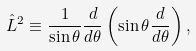<formula> <loc_0><loc_0><loc_500><loc_500>\hat { L } ^ { 2 } \equiv \frac { 1 } { \sin { \theta } } \frac { d } { d \theta } \left ( \sin { \theta } \frac { d } { d \theta } \right ) ,</formula> 